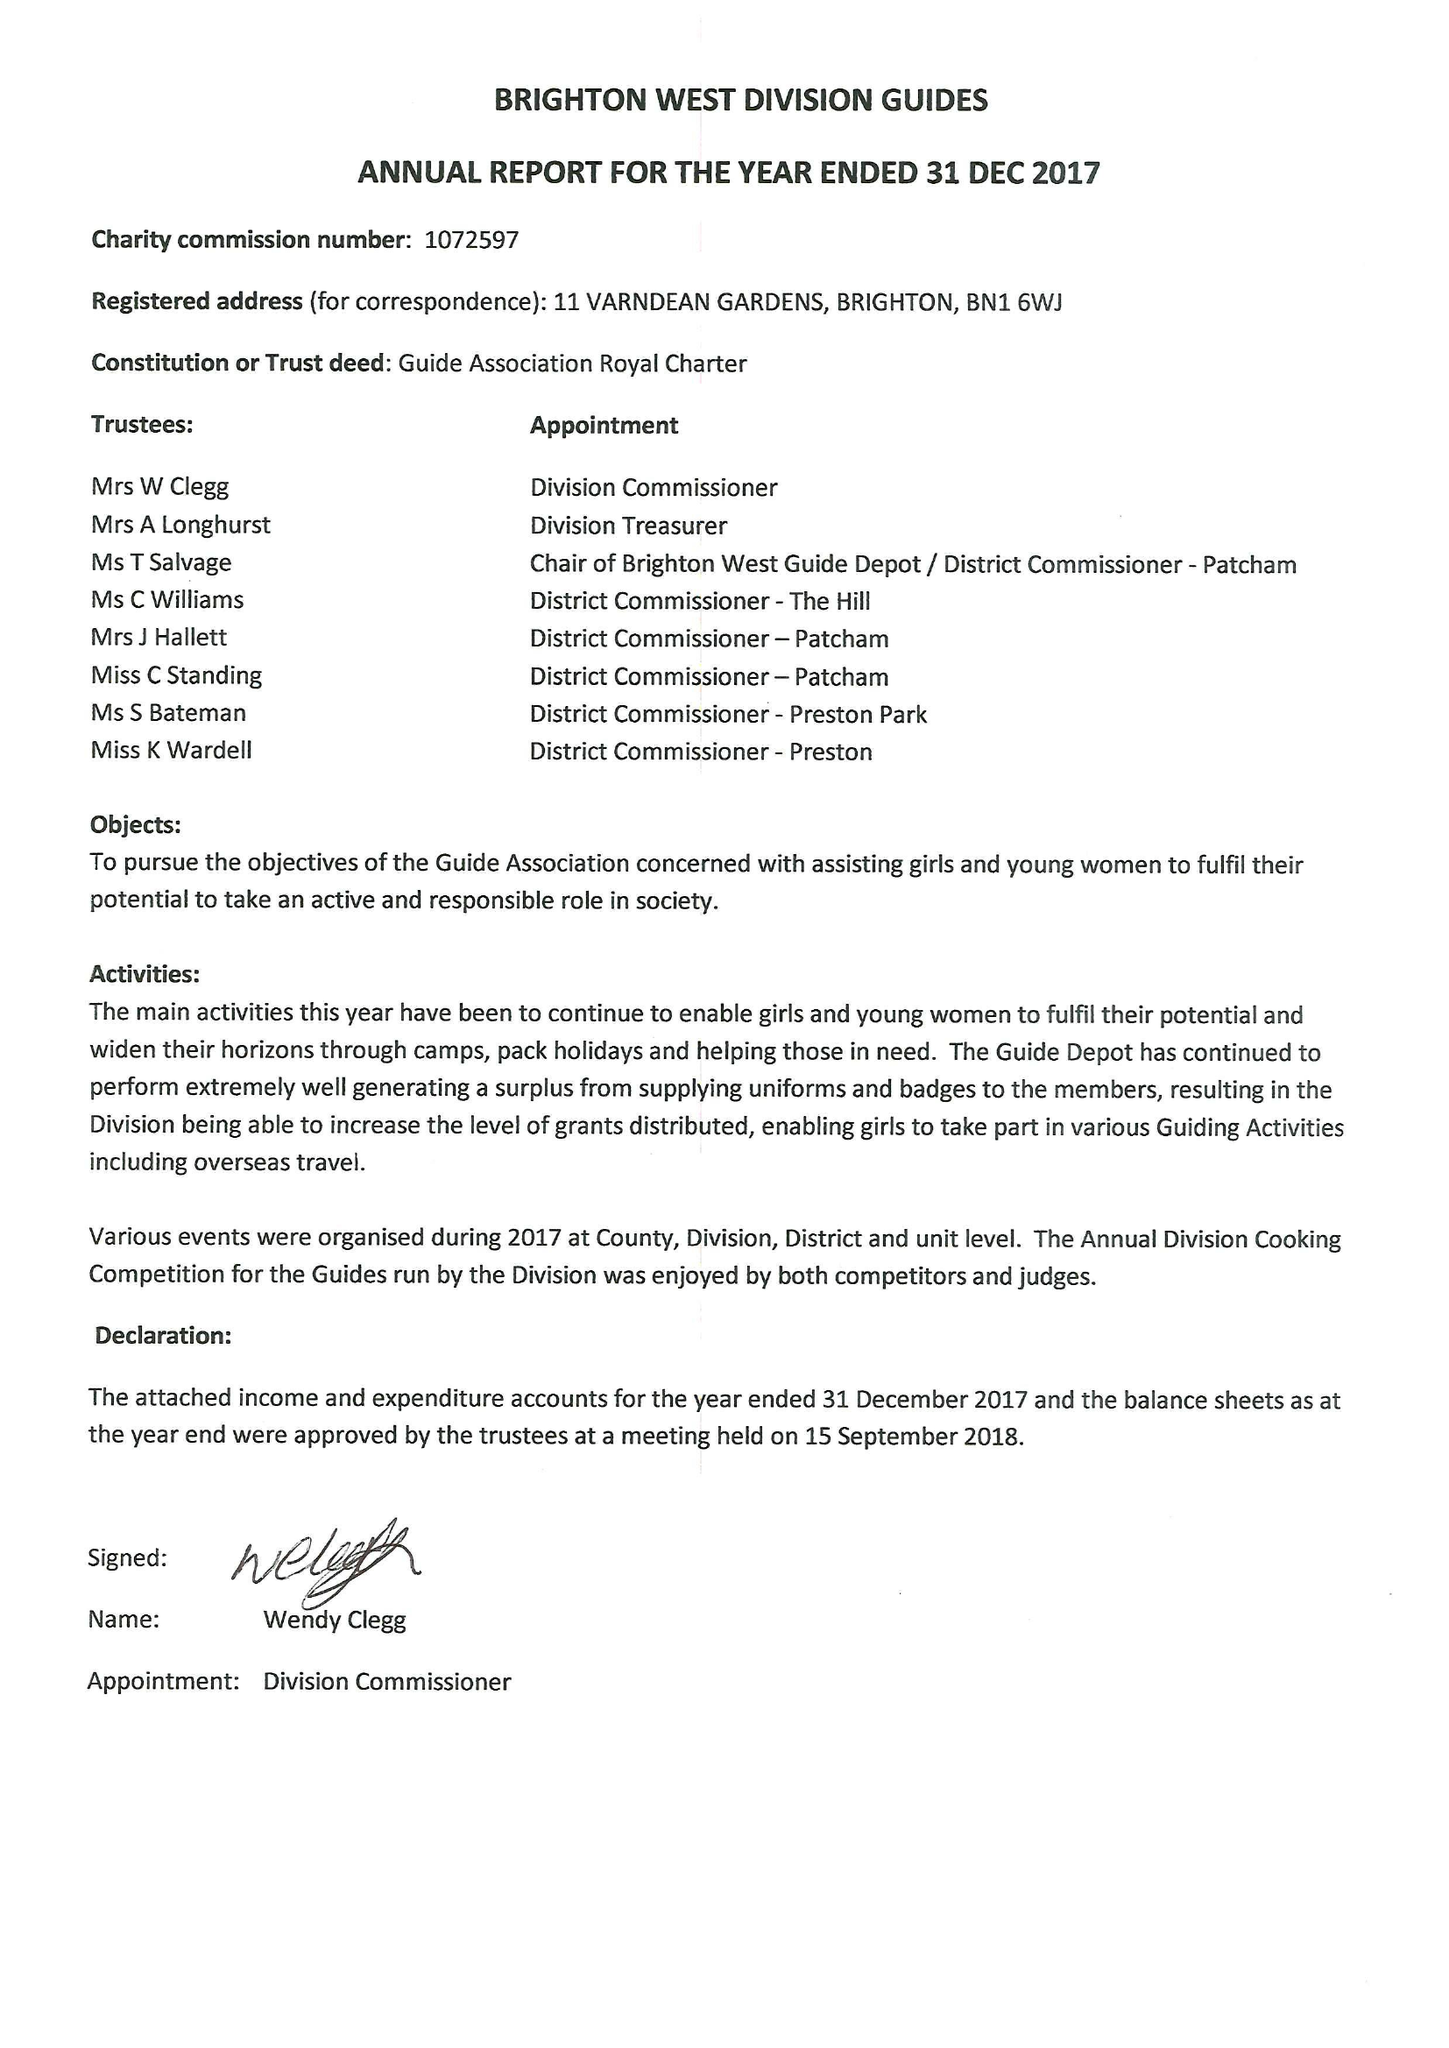What is the value for the address__postcode?
Answer the question using a single word or phrase. BN1 6WJ 